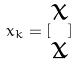Convert formula to latex. <formula><loc_0><loc_0><loc_500><loc_500>x _ { k } = [ \begin{matrix} x \\ \dot { x } \end{matrix} ]</formula> 